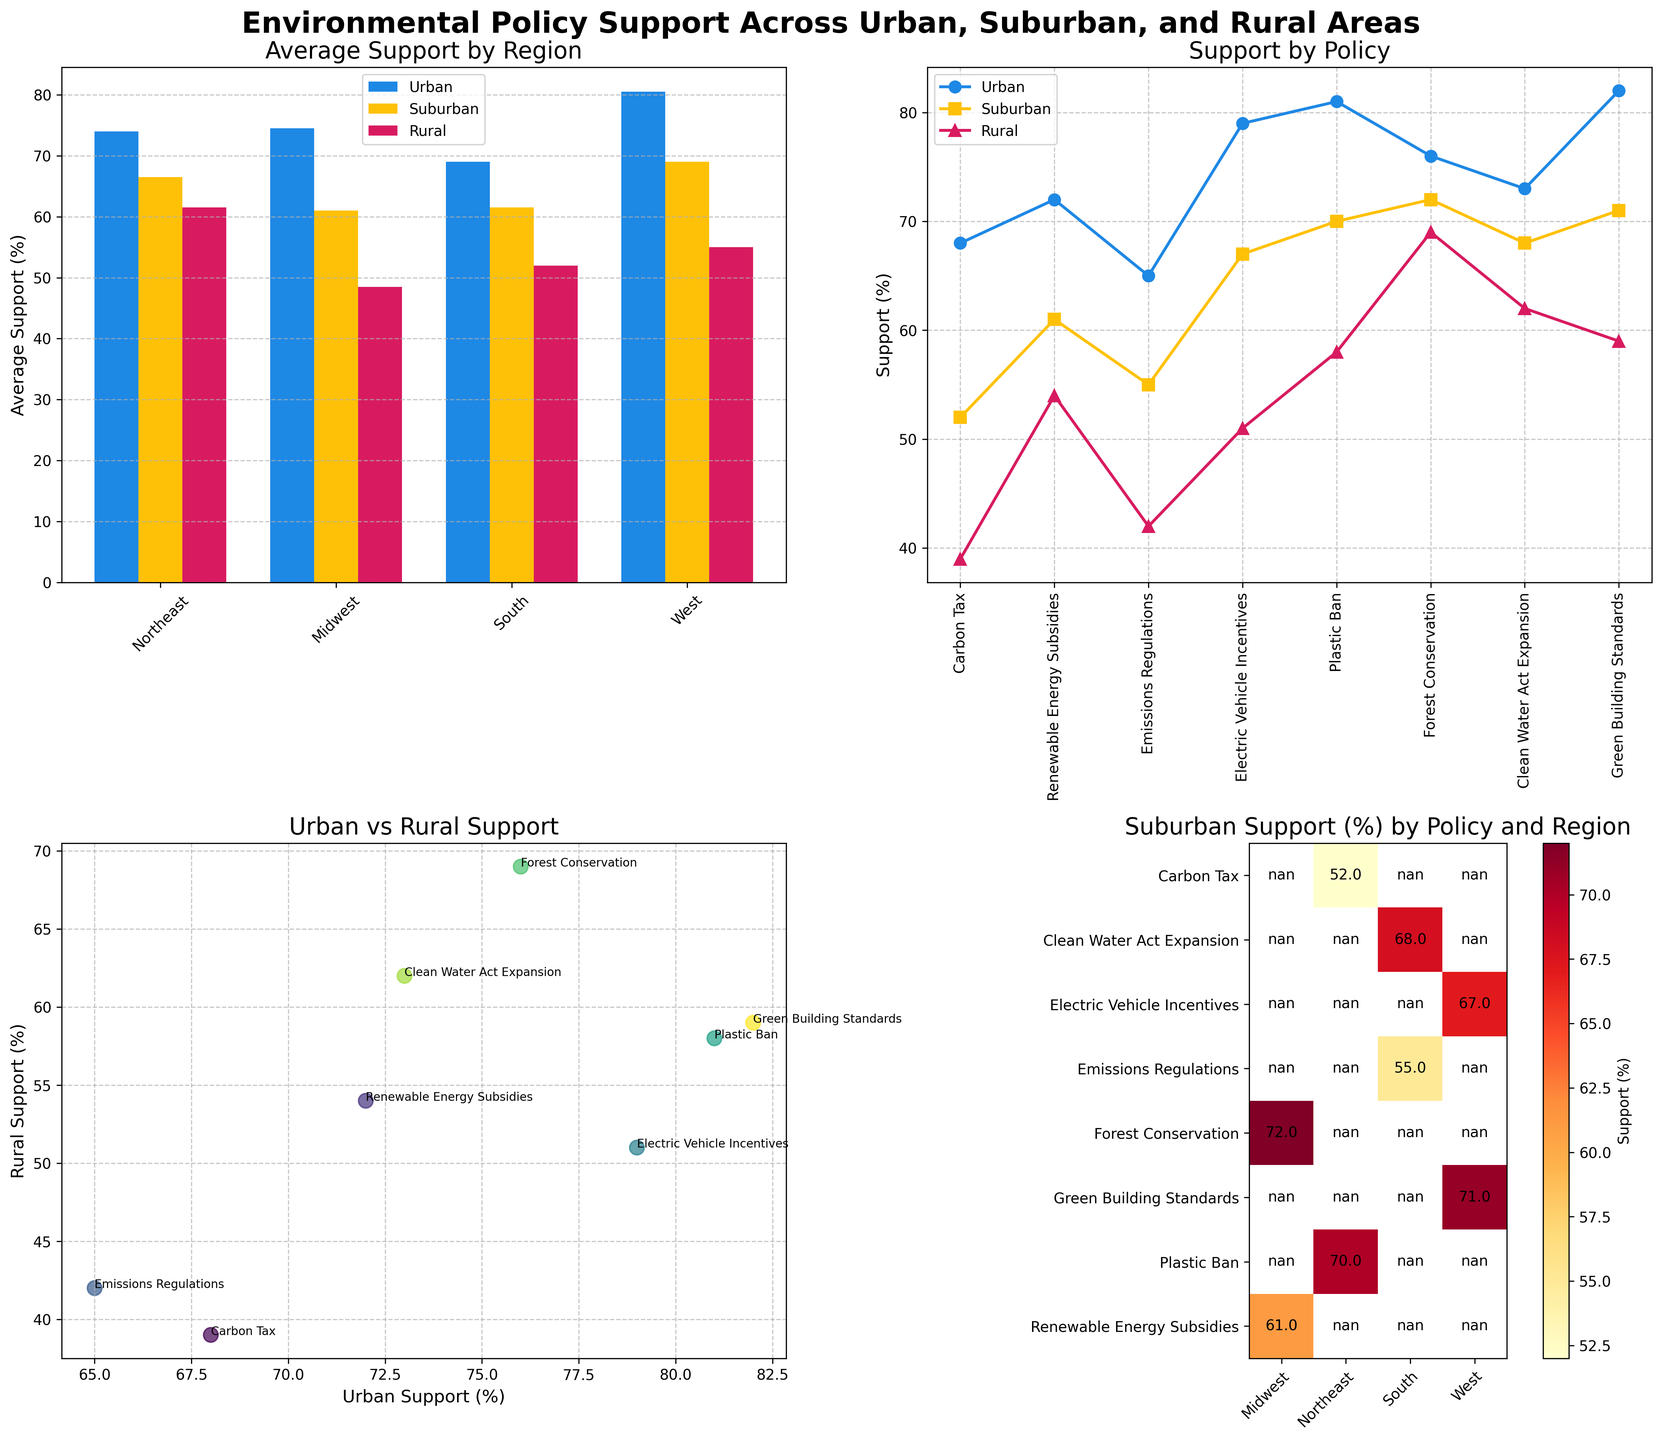What is the title of the bar plot? The title of the bar plot is written at the top of the subplot in the first row and first column. It is always used to describe the content of the plot.
Answer: Average Support by Region Which region has the highest average urban support? Find the tallest bar with the label "Urban" in the bar plot under each region. The tallest bar indicates the highest average urban support.
Answer: West How does the support for Forest Conservation compare across urban, suburban, and rural areas? In the line plot, find the points corresponding to "Forest Conservation" for urban, suburban, and rural. Compare their positions vertically to see the support levels.
Answer: Urban: 76%, Suburban: 72%, Rural: 69% What’s the average of Suburban Support (%) for the policies shown in the line plot? To find the average, add all the suburban support values shown in the line plot and divide by the number of policies. (52+61+55+67+70+72+68+71)/8 = 67%
Answer: 67% Which policy has the lowest support in rural areas? In the line plot, find the policy corresponding to the lowest point on the "Rural" line with marker "^".
Answer: Carbon Tax What do the colors represent in the scatter plot? The colors in the scatter plot are used to differentiate the policies. Each policy is represented by a different point color on the plot.
Answer: Different policies What’s the difference in suburban support between the Clean Water Act Expansion in the South and Electric Vehicle Incentives in the West? In the heatmap plot, find the cells corresponding to these policies and regions. Subtract the support value of the Clean Water Act Expansion from Electric Vehicle Incentives. 67 - 68 = -1%
Answer: -1% What region and policy combination has the highest suburban support? In the heatmap plot, look for the cell with the highest value. Read off the region and policy combination from the row and column labels.
Answer: Green Building Standards in the West Is there a visible relationship between urban and rural support from the scatter plot? In the scatter plot, observe the spread and clustering of points. If there is a clear trend (like a diagonal line), it indicates a relationship.
Answer: No clear relationship Which has more variation in the line plot: Urban Support (%) or Rural Support (%)? Compare the fluctuation range of the urban and rural lines. Calculate the difference between the highest and lowest points on each line to determine which has more variation. Urban: 68-81 = 13; Rural: 39-69 = 30
Answer: Rural Support (%) 